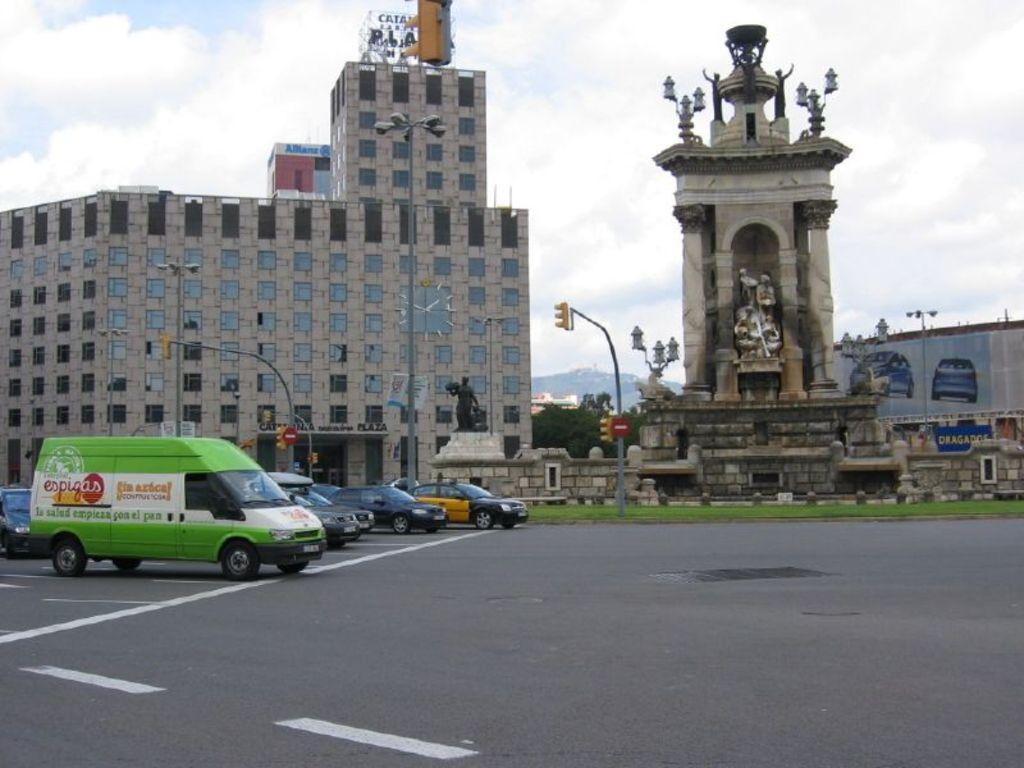How would you summarize this image in a sentence or two? In this I can see buildings and a tower with a statue and I can see few cars and a van on the road and I can see couple of traffic signal lights to the poles and a statue in the middle of the picture and I can see a cloudy sky and few trees. 